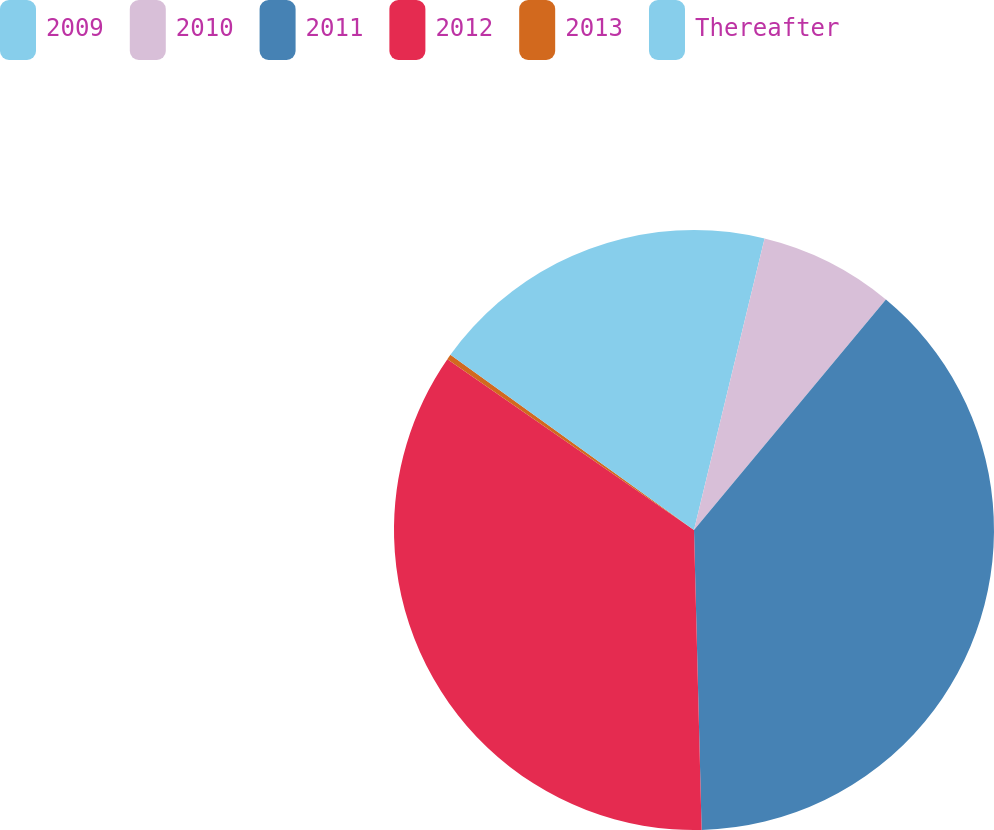<chart> <loc_0><loc_0><loc_500><loc_500><pie_chart><fcel>2009<fcel>2010<fcel>2011<fcel>2012<fcel>2013<fcel>Thereafter<nl><fcel>3.78%<fcel>7.27%<fcel>38.55%<fcel>35.05%<fcel>0.28%<fcel>15.08%<nl></chart> 